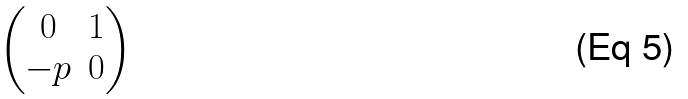Convert formula to latex. <formula><loc_0><loc_0><loc_500><loc_500>\begin{pmatrix} 0 & 1 \\ - p & 0 \end{pmatrix}</formula> 